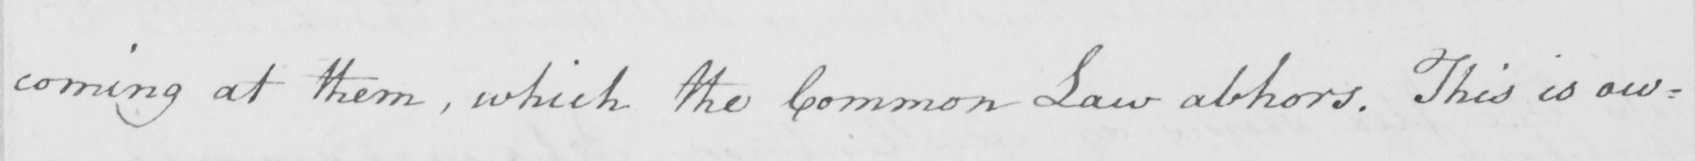What is written in this line of handwriting? coming at them , which the Common Law abhors . This is ow= 